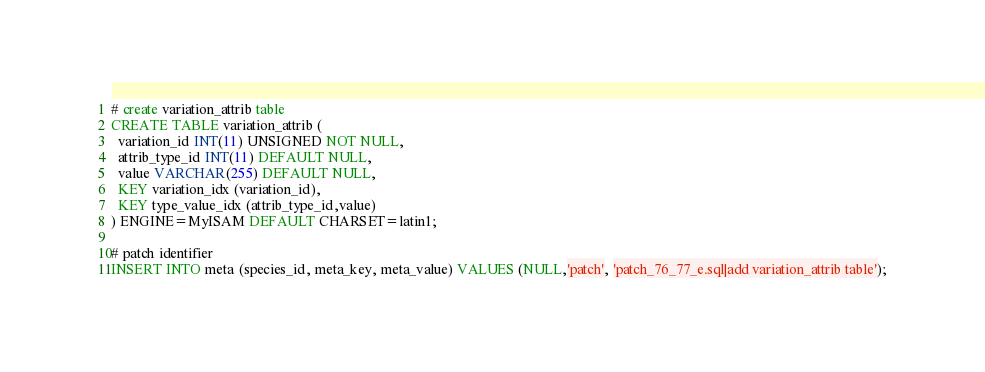<code> <loc_0><loc_0><loc_500><loc_500><_SQL_># create variation_attrib table
CREATE TABLE variation_attrib (
  variation_id INT(11) UNSIGNED NOT NULL,
  attrib_type_id INT(11) DEFAULT NULL,
  value VARCHAR(255) DEFAULT NULL,
  KEY variation_idx (variation_id),
  KEY type_value_idx (attrib_type_id,value)
) ENGINE=MyISAM DEFAULT CHARSET=latin1;

# patch identifier
INSERT INTO meta (species_id, meta_key, meta_value) VALUES (NULL,'patch', 'patch_76_77_e.sql|add variation_attrib table');
</code> 